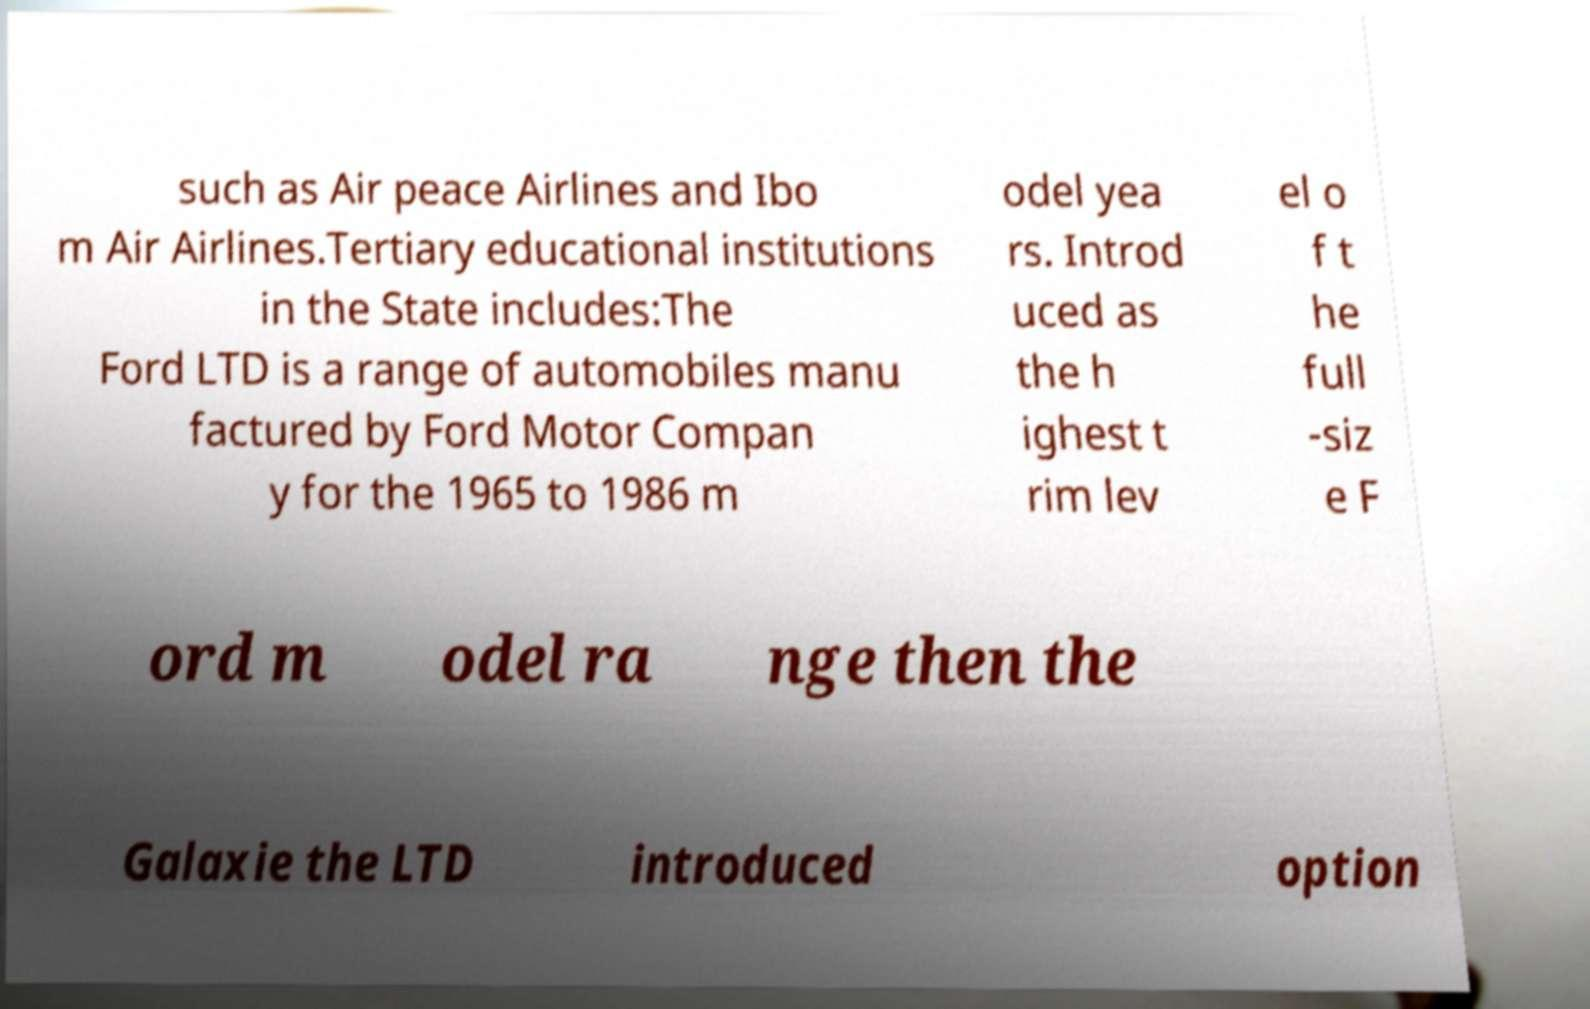What messages or text are displayed in this image? I need them in a readable, typed format. such as Air peace Airlines and Ibo m Air Airlines.Tertiary educational institutions in the State includes:The Ford LTD is a range of automobiles manu factured by Ford Motor Compan y for the 1965 to 1986 m odel yea rs. Introd uced as the h ighest t rim lev el o f t he full -siz e F ord m odel ra nge then the Galaxie the LTD introduced option 